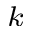<formula> <loc_0><loc_0><loc_500><loc_500>^ { k }</formula> 